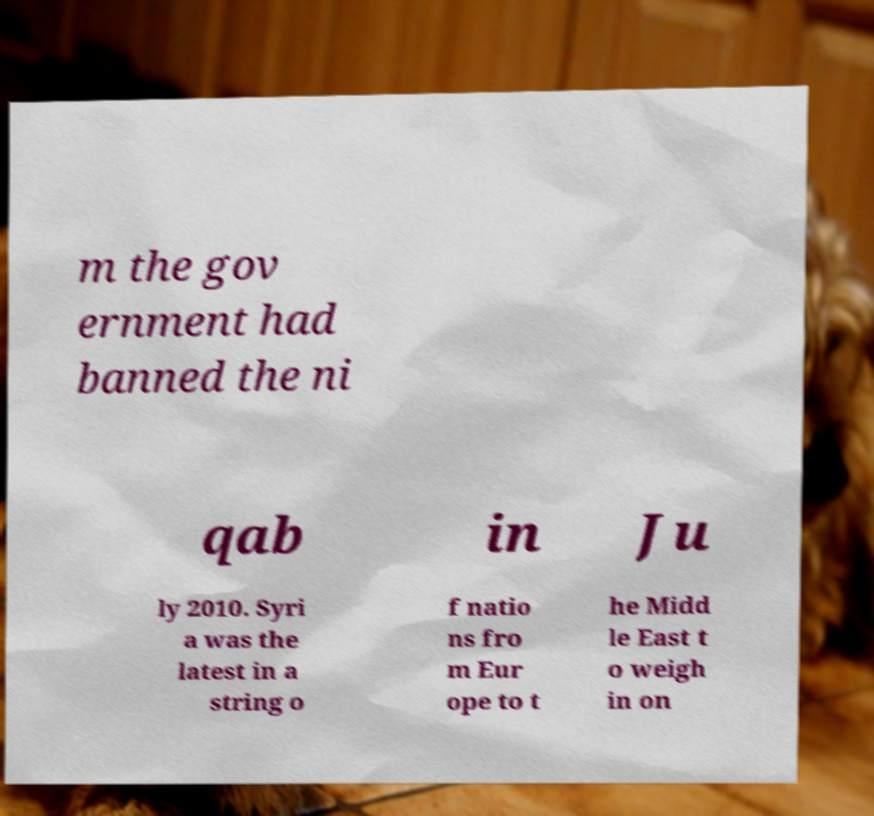I need the written content from this picture converted into text. Can you do that? m the gov ernment had banned the ni qab in Ju ly 2010. Syri a was the latest in a string o f natio ns fro m Eur ope to t he Midd le East t o weigh in on 